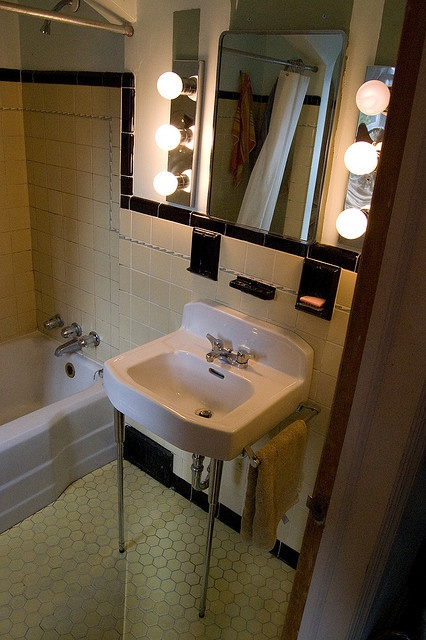Describe the objects in this image and their specific colors. I can see a sink in black, darkgray, gray, tan, and maroon tones in this image. 